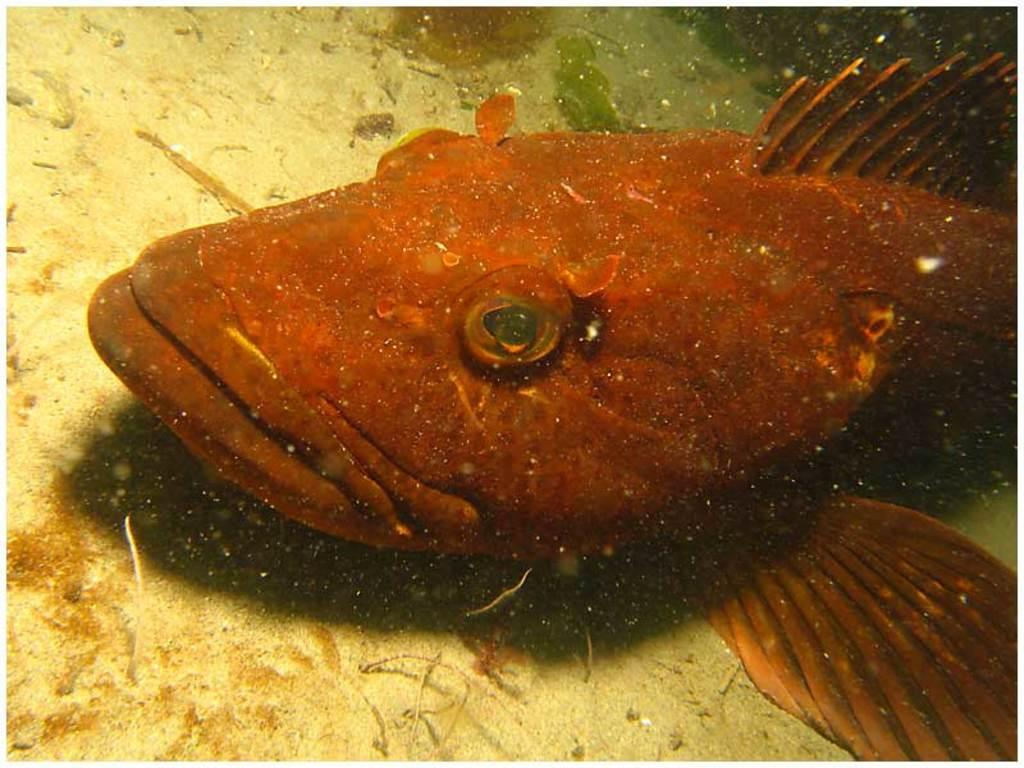What is the main subject in the center of the image? There is a fish in the center of the image. Where is the fish located? The fish appears to be in an aquarium. What else can be seen in the image besides the fish? There are other items visible in the image. How many ladybugs are playing with the balls in the image? There are no ladybugs or balls present in the image. 